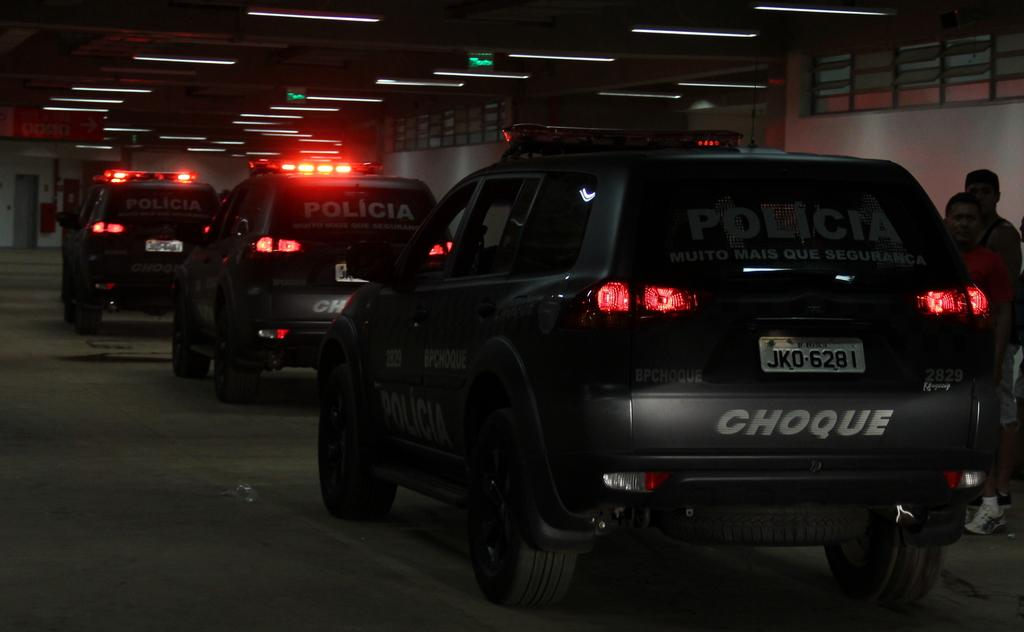<image>
Write a terse but informative summary of the picture. the word choque which is on the back of a car 